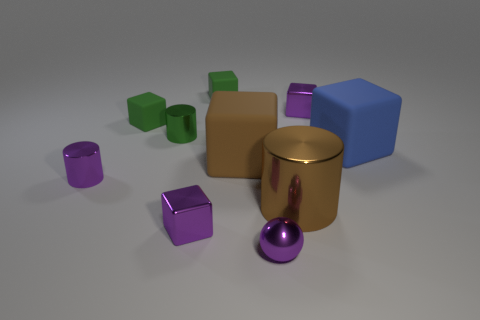Is there anything else that is the same size as the purple cylinder?
Your answer should be very brief. Yes. What material is the cube that is the same color as the large cylinder?
Ensure brevity in your answer.  Rubber. Is there a green matte thing that has the same shape as the large brown metal thing?
Give a very brief answer. No. How big is the blue rubber thing that is behind the big metallic cylinder?
Provide a succinct answer. Large. What is the material of the other cylinder that is the same size as the purple shiny cylinder?
Ensure brevity in your answer.  Metal. Is the number of large brown blocks greater than the number of small red shiny cylinders?
Your response must be concise. Yes. How big is the green object that is behind the tiny purple block behind the big brown rubber object?
Offer a very short reply. Small. What is the shape of the green metallic thing that is the same size as the sphere?
Keep it short and to the point. Cylinder. The purple metallic thing in front of the purple cube that is on the left side of the large matte cube that is to the left of the large brown metallic thing is what shape?
Your answer should be compact. Sphere. There is a rubber block that is right of the tiny purple sphere; is its color the same as the large rubber block to the left of the purple sphere?
Provide a short and direct response. No. 